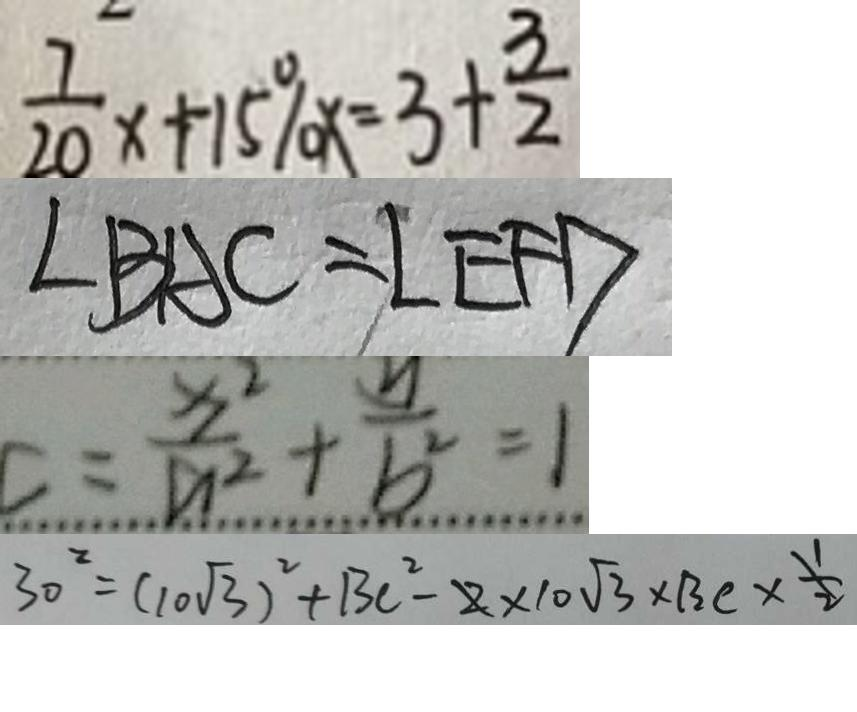Convert formula to latex. <formula><loc_0><loc_0><loc_500><loc_500>\frac { 7 } { 2 0 } x + 1 5 \% x = 3 + \frac { 3 } { 2 } 
 \angle B A C = \angle E F D 
 C = \frac { x ^ { 2 } } { a ^ { 2 } } + \frac { y } { b ^ { 2 } } = 1 
 3 0 ^ { 2 } = ( 1 0 \sqrt { 3 } ) ^ { 2 } + B C ^ { 2 } - 2 \times 1 0 \sqrt { 3 } \times B C \times \frac { 1 } { 2 }</formula> 